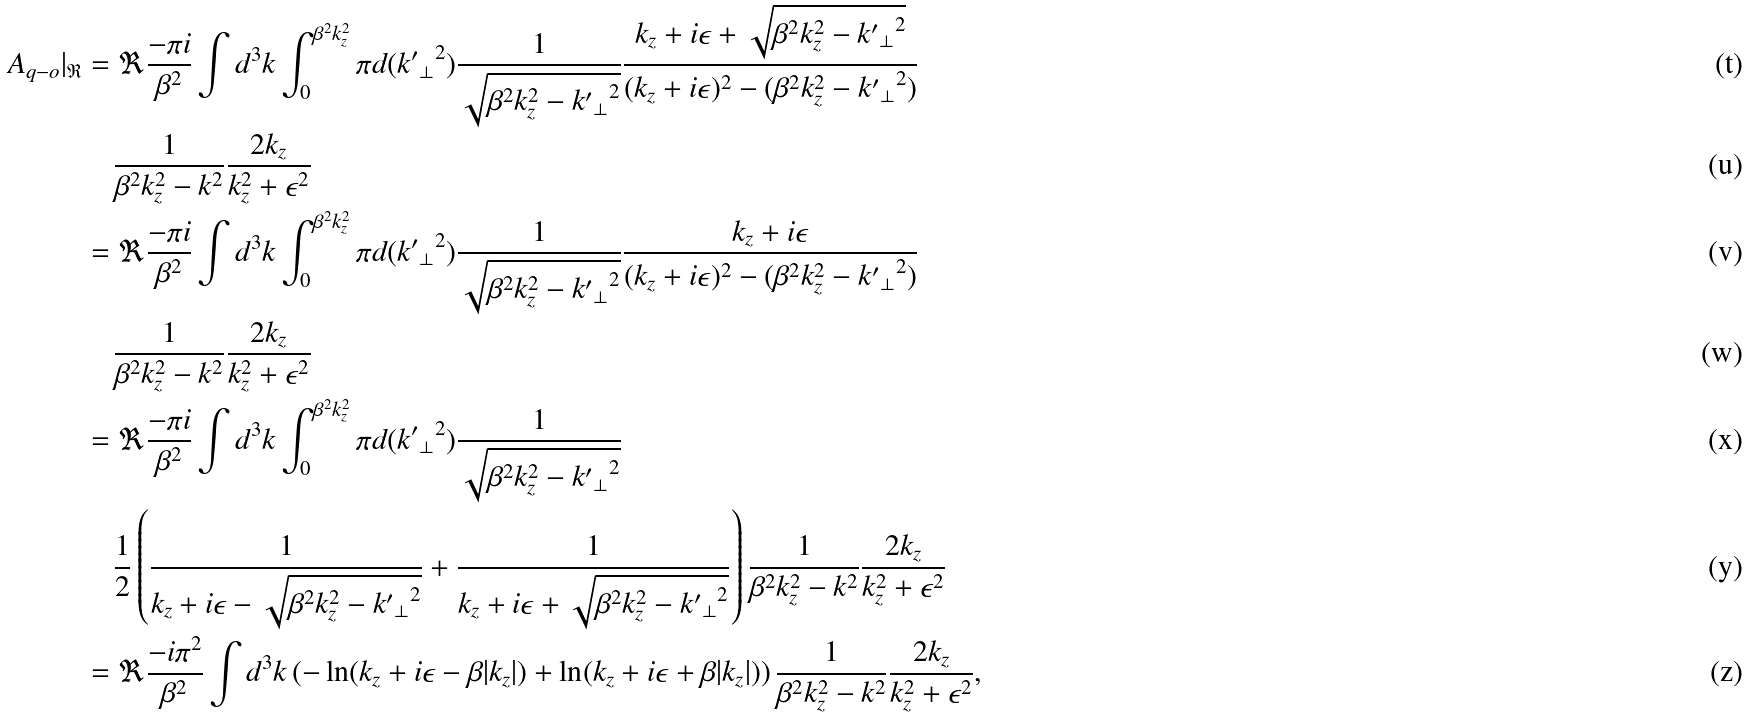<formula> <loc_0><loc_0><loc_500><loc_500>A _ { q - o } | _ { \mathfrak R } & = \Re \frac { - \pi i } { \beta ^ { 2 } } \int d ^ { 3 } k \int _ { 0 } ^ { \beta ^ { 2 } k _ { z } ^ { 2 } } \pi d ( { { k ^ { \prime } } _ { \perp } } ^ { 2 } ) \frac { 1 } { \sqrt { \beta ^ { 2 } k _ { z } ^ { 2 } - { { k ^ { \prime } } _ { \perp } } ^ { 2 } } } \frac { k _ { z } + i \epsilon + \sqrt { \beta ^ { 2 } k _ { z } ^ { 2 } - { { k ^ { \prime } } _ { \perp } } ^ { 2 } } } { ( k _ { z } + i \epsilon ) ^ { 2 } - ( \beta ^ { 2 } k _ { z } ^ { 2 } - { { k ^ { \prime } } _ { \perp } } ^ { 2 } ) } \\ & \quad \frac { 1 } { \beta ^ { 2 } k _ { z } ^ { 2 } - { k } ^ { 2 } } \frac { 2 k _ { z } } { k _ { z } ^ { 2 } + \epsilon ^ { 2 } } \\ & = \Re \frac { - \pi i } { \beta ^ { 2 } } \int d ^ { 3 } k \int _ { 0 } ^ { \beta ^ { 2 } k _ { z } ^ { 2 } } \pi d ( { { k ^ { \prime } } _ { \perp } } ^ { 2 } ) \frac { 1 } { \sqrt { \beta ^ { 2 } k _ { z } ^ { 2 } - { { k ^ { \prime } } _ { \perp } } ^ { 2 } } } \frac { k _ { z } + i \epsilon } { ( k _ { z } + i \epsilon ) ^ { 2 } - ( \beta ^ { 2 } k _ { z } ^ { 2 } - { { k ^ { \prime } } _ { \perp } } ^ { 2 } ) } \\ & \quad \frac { 1 } { \beta ^ { 2 } k _ { z } ^ { 2 } - { k } ^ { 2 } } \frac { 2 k _ { z } } { k _ { z } ^ { 2 } + \epsilon ^ { 2 } } \\ & = \Re \frac { - \pi i } { \beta ^ { 2 } } \int d ^ { 3 } k \int _ { 0 } ^ { \beta ^ { 2 } k _ { z } ^ { 2 } } \pi d ( { { k ^ { \prime } } _ { \perp } } ^ { 2 } ) \frac { 1 } { \sqrt { \beta ^ { 2 } k _ { z } ^ { 2 } - { { k ^ { \prime } } _ { \perp } } ^ { 2 } } } \\ & \quad \frac { 1 } { 2 } \left ( \frac { 1 } { k _ { z } + i \epsilon - \sqrt { \beta ^ { 2 } k _ { z } ^ { 2 } - { { k ^ { \prime } } _ { \perp } } ^ { 2 } } } + \frac { 1 } { k _ { z } + i \epsilon + \sqrt { \beta ^ { 2 } k _ { z } ^ { 2 } - { { k ^ { \prime } } _ { \perp } } ^ { 2 } } } \right ) \frac { 1 } { \beta ^ { 2 } k _ { z } ^ { 2 } - { k } ^ { 2 } } \frac { 2 k _ { z } } { k _ { z } ^ { 2 } + \epsilon ^ { 2 } } \\ & = \Re \frac { - i \pi ^ { 2 } } { \beta ^ { 2 } } \int d ^ { 3 } k \left ( - \ln ( k _ { z } + i \epsilon - \beta | k _ { z } | ) + \ln ( k _ { z } + i \epsilon + \beta | k _ { z } | ) \right ) \frac { 1 } { \beta ^ { 2 } k _ { z } ^ { 2 } - { k } ^ { 2 } } \frac { 2 k _ { z } } { k _ { z } ^ { 2 } + \epsilon ^ { 2 } } ,</formula> 